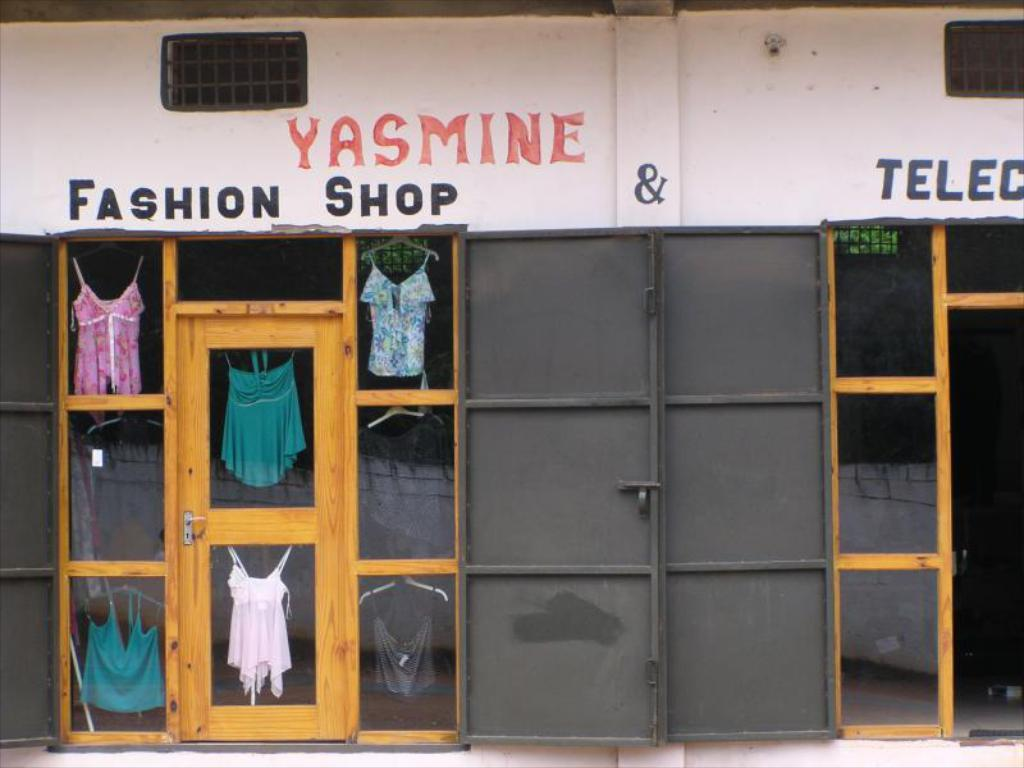<image>
Render a clear and concise summary of the photo. The doorway of Yasmine Fashion Shop shows a few shirts in glass 